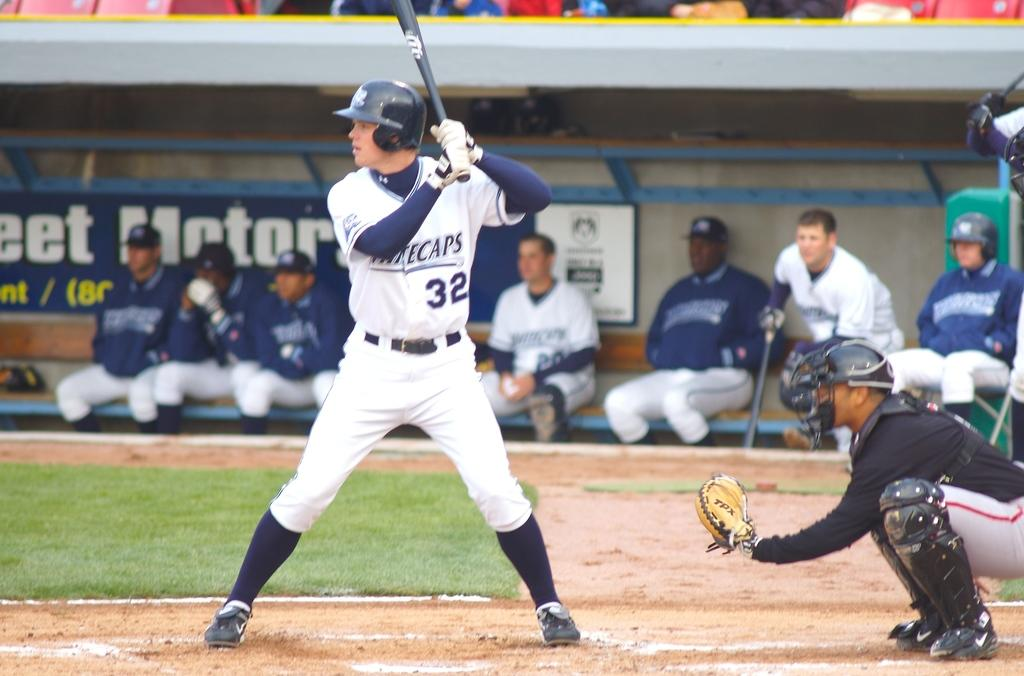<image>
Offer a succinct explanation of the picture presented. On a baseball field a baseball player is up to bat and is dressed in a white and blue jersey with the team name WHITECAPS printed on the front. 